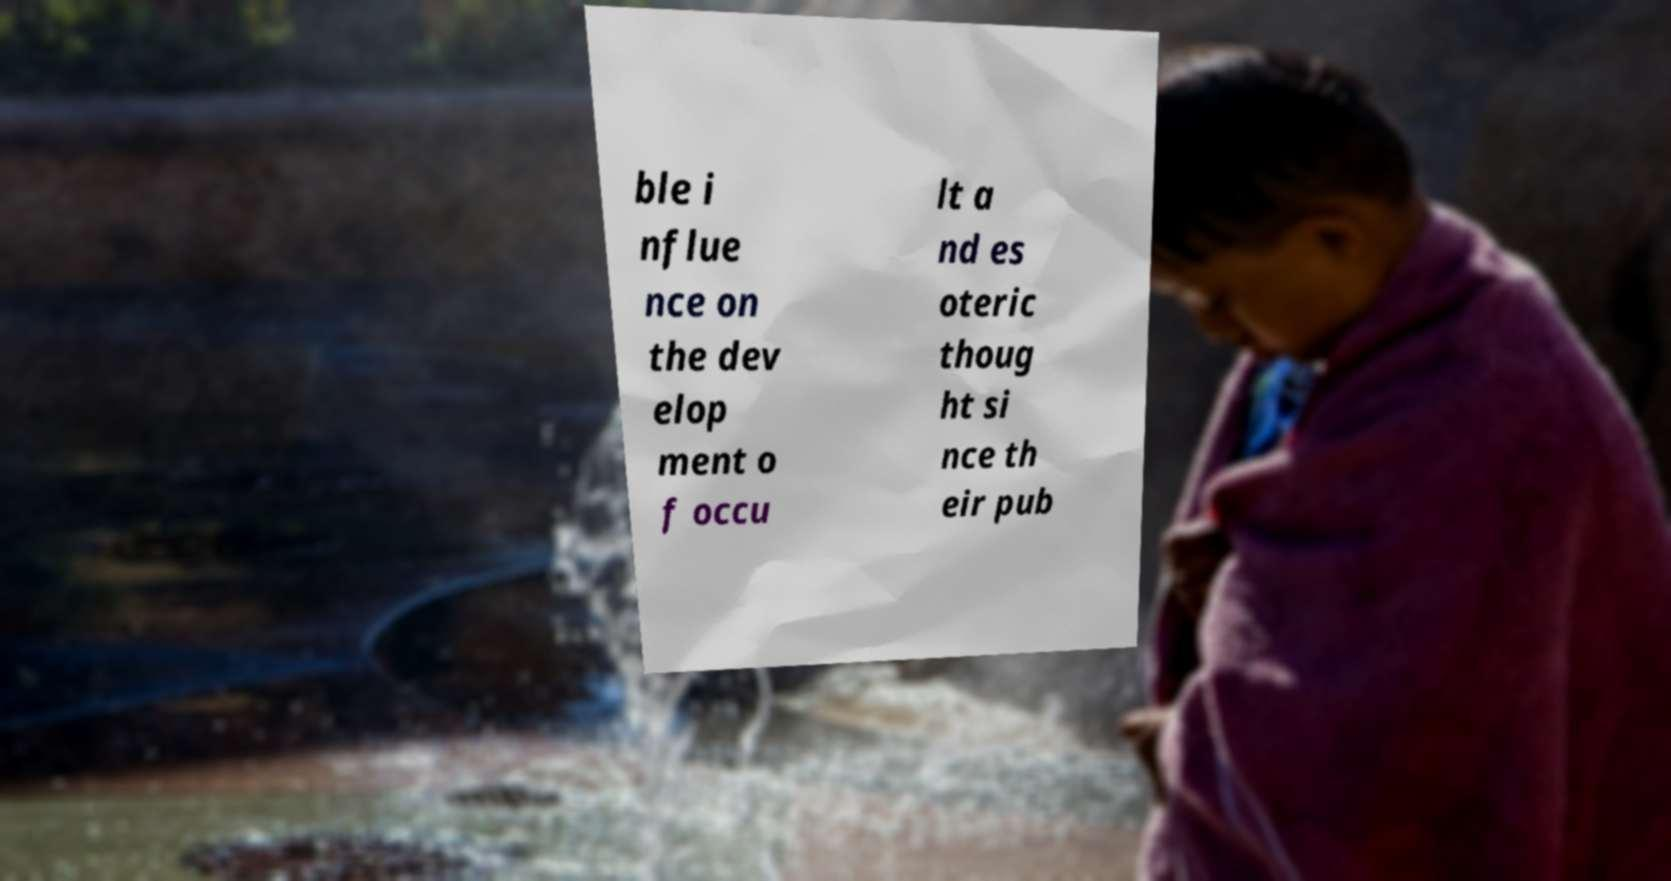Please identify and transcribe the text found in this image. ble i nflue nce on the dev elop ment o f occu lt a nd es oteric thoug ht si nce th eir pub 